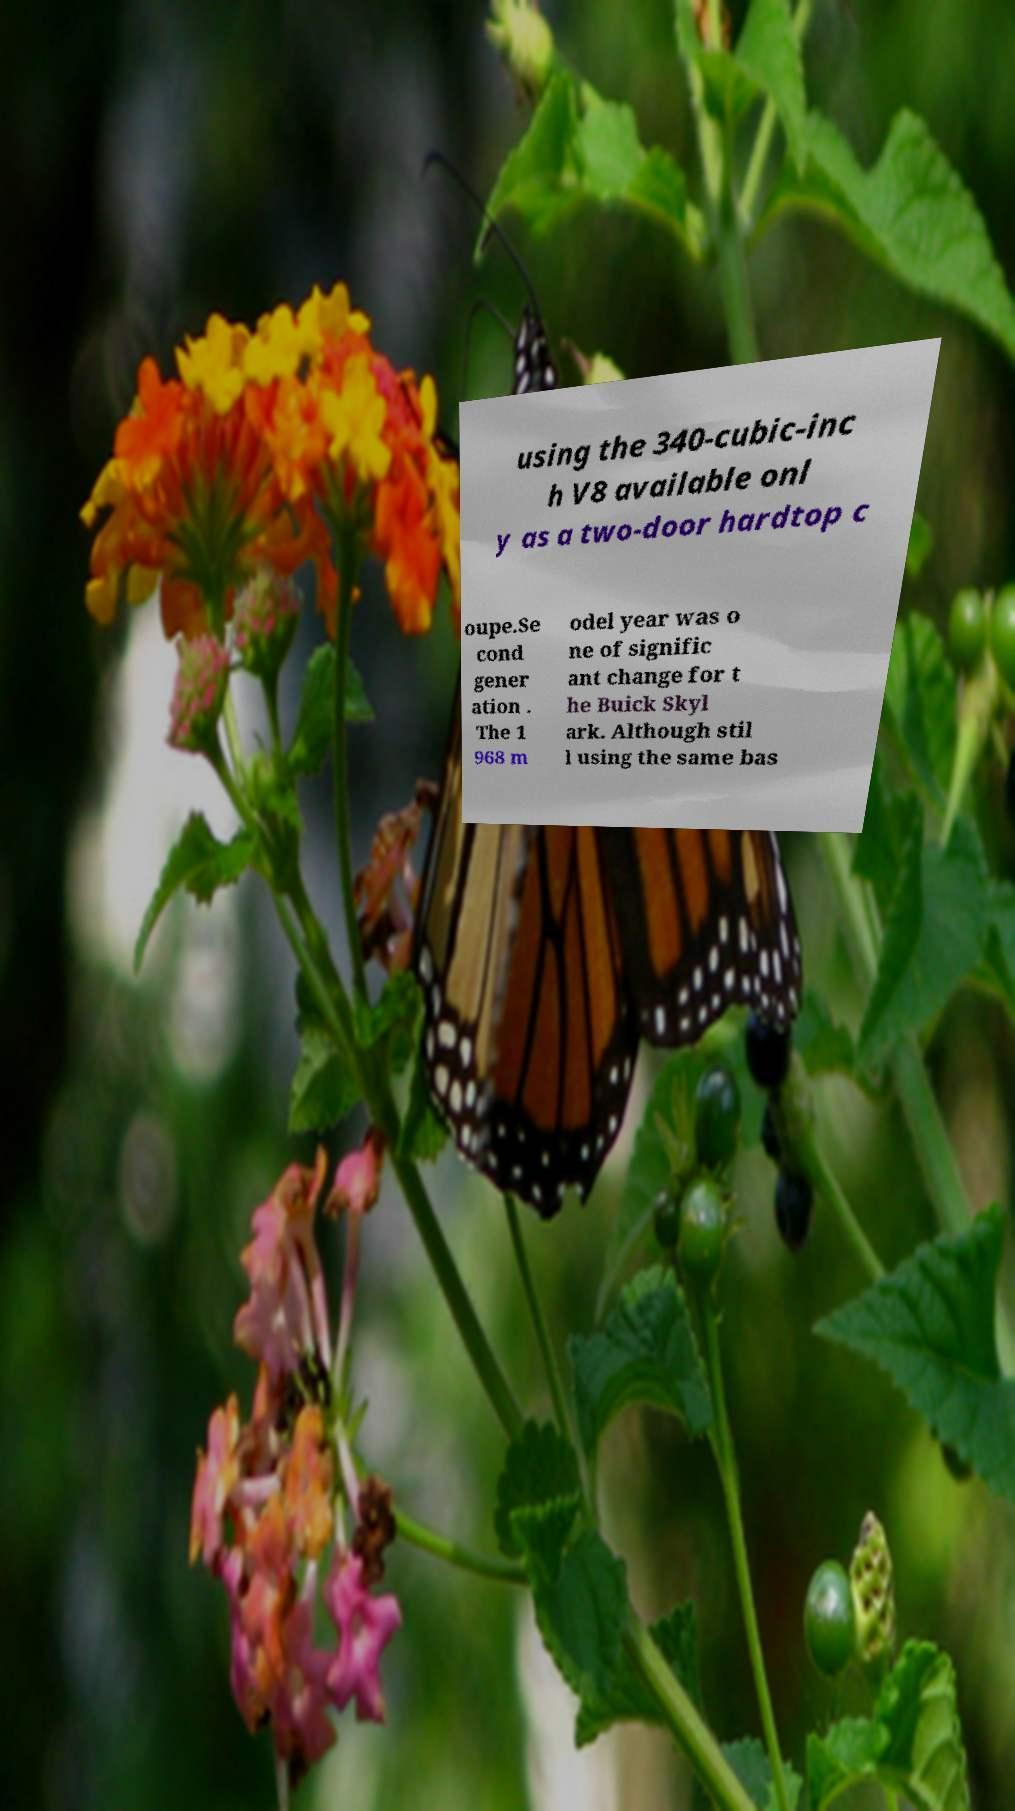Could you extract and type out the text from this image? using the 340-cubic-inc h V8 available onl y as a two-door hardtop c oupe.Se cond gener ation . The 1 968 m odel year was o ne of signific ant change for t he Buick Skyl ark. Although stil l using the same bas 